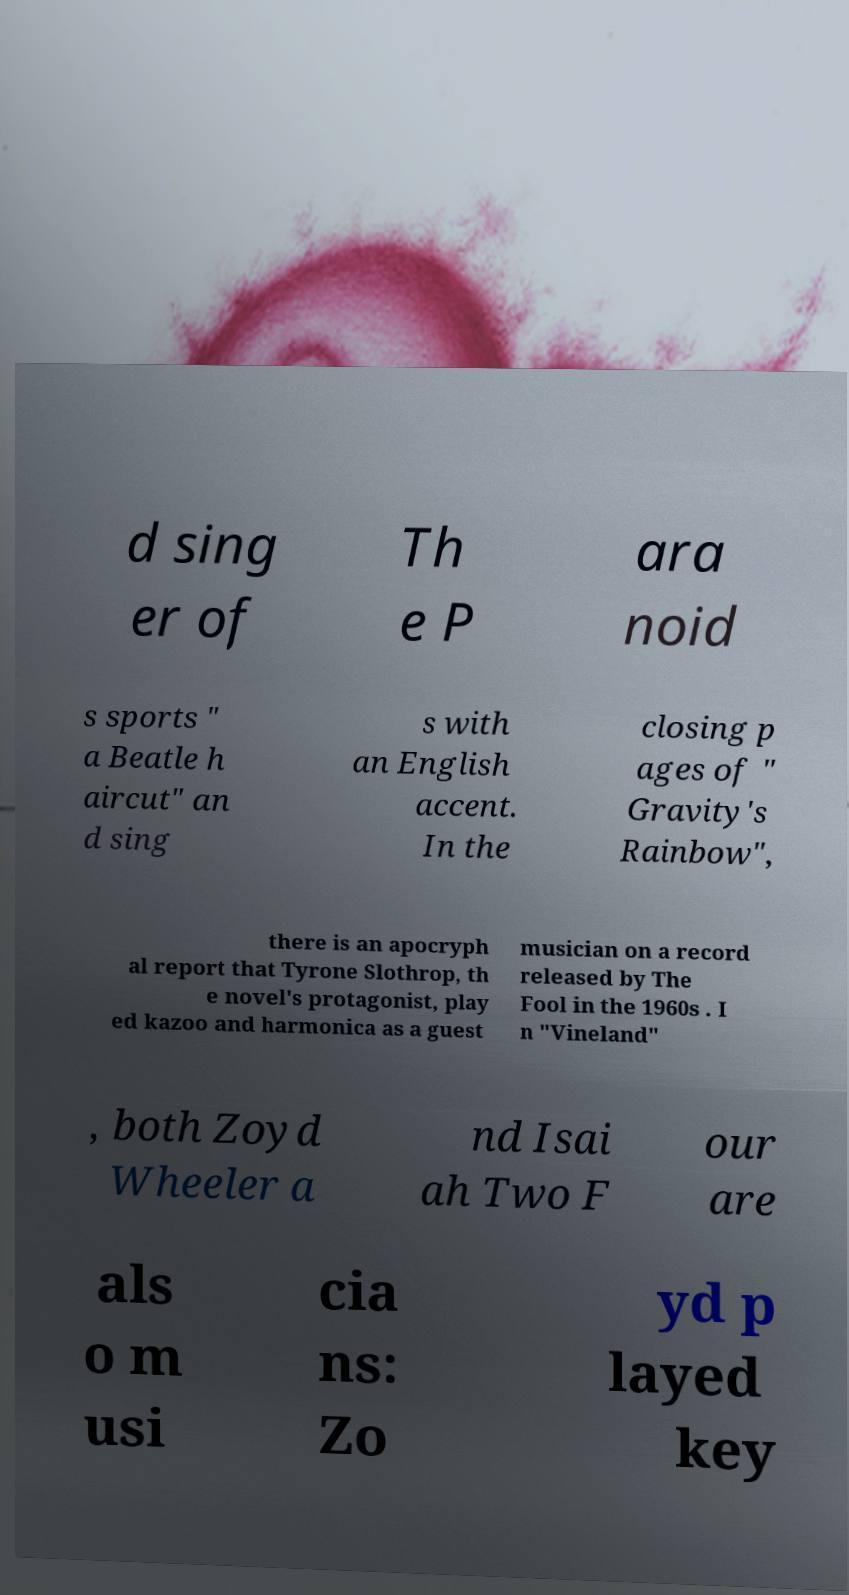Could you extract and type out the text from this image? d sing er of Th e P ara noid s sports " a Beatle h aircut" an d sing s with an English accent. In the closing p ages of " Gravity's Rainbow", there is an apocryph al report that Tyrone Slothrop, th e novel's protagonist, play ed kazoo and harmonica as a guest musician on a record released by The Fool in the 1960s . I n "Vineland" , both Zoyd Wheeler a nd Isai ah Two F our are als o m usi cia ns: Zo yd p layed key 